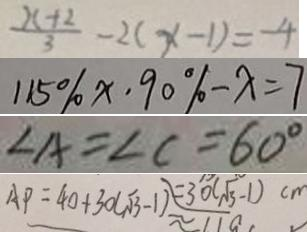Convert formula to latex. <formula><loc_0><loc_0><loc_500><loc_500>\frac { x + 2 } { 3 } - 2 ( x - 1 ) = - 4 
 1 1 5 \% x \cdot 9 0 \% - x = 7 
 \angle A = \angle C = 6 0 ^ { \circ } 
 A P = 4 0 + 3 0 ( \sqrt { 3 } - 1 ) = 3 0 ( \sqrt { 3 } - 1 ) c m</formula> 